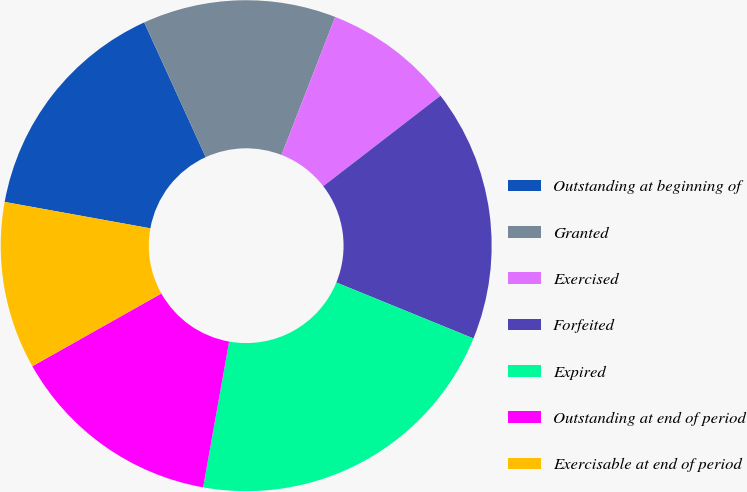<chart> <loc_0><loc_0><loc_500><loc_500><pie_chart><fcel>Outstanding at beginning of<fcel>Granted<fcel>Exercised<fcel>Forfeited<fcel>Expired<fcel>Outstanding at end of period<fcel>Exercisable at end of period<nl><fcel>15.33%<fcel>12.73%<fcel>8.63%<fcel>16.63%<fcel>21.64%<fcel>14.03%<fcel>11.02%<nl></chart> 